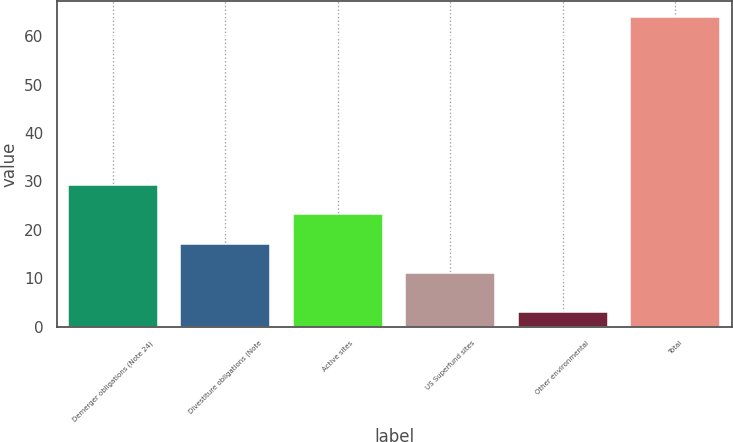Convert chart to OTSL. <chart><loc_0><loc_0><loc_500><loc_500><bar_chart><fcel>Demerger obligations (Note 24)<fcel>Divestiture obligations (Note<fcel>Active sites<fcel>US Superfund sites<fcel>Other environmental<fcel>Total<nl><fcel>29.3<fcel>17.1<fcel>23.2<fcel>11<fcel>3<fcel>64<nl></chart> 